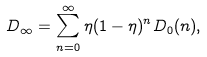Convert formula to latex. <formula><loc_0><loc_0><loc_500><loc_500>D _ { \infty } = \sum ^ { \infty } _ { n = 0 } \eta ( 1 - \eta ) ^ { n } D _ { 0 } ( n ) ,</formula> 